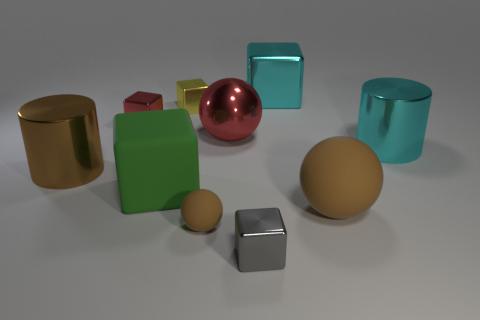How many cyan cylinders have the same material as the small red block?
Your response must be concise. 1. Does the red thing in front of the red metal block have the same size as the tiny yellow cube?
Provide a short and direct response. No. What color is the big object that is made of the same material as the green block?
Provide a succinct answer. Brown. Are there any other things that have the same size as the red shiny ball?
Your response must be concise. Yes. How many red spheres are behind the metal sphere?
Ensure brevity in your answer.  0. Does the small thing on the right side of the large red sphere have the same color as the large metal cylinder that is in front of the cyan metallic cylinder?
Offer a very short reply. No. What is the color of the big matte thing that is the same shape as the small brown matte object?
Offer a terse response. Brown. Are there any other things that have the same shape as the large red thing?
Your response must be concise. Yes. Do the large cyan object that is left of the big brown matte object and the large thing that is right of the big matte sphere have the same shape?
Offer a terse response. No. Does the green rubber object have the same size as the cyan metal thing to the left of the big brown rubber sphere?
Ensure brevity in your answer.  Yes. 